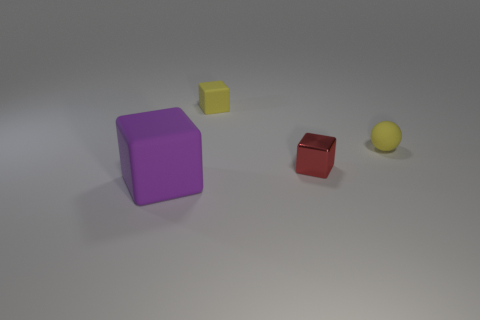Subtract all small yellow rubber blocks. How many blocks are left? 2 Add 4 yellow rubber blocks. How many objects exist? 8 Subtract all yellow cubes. How many cubes are left? 2 Subtract all cubes. How many objects are left? 1 Subtract 3 cubes. How many cubes are left? 0 Add 2 tiny yellow spheres. How many tiny yellow spheres are left? 3 Add 2 small red shiny balls. How many small red shiny balls exist? 2 Subtract 0 red spheres. How many objects are left? 4 Subtract all green spheres. Subtract all yellow cylinders. How many spheres are left? 1 Subtract all green blocks. Subtract all large purple objects. How many objects are left? 3 